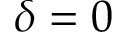Convert formula to latex. <formula><loc_0><loc_0><loc_500><loc_500>\delta = 0</formula> 